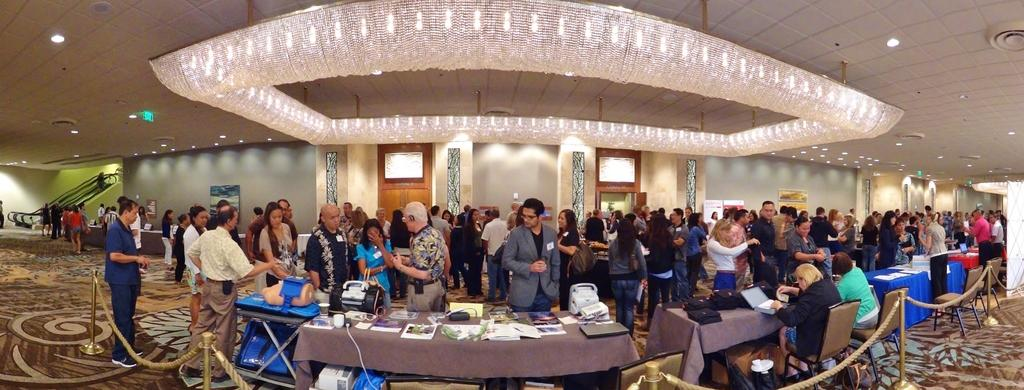What are the people in the image doing? There is a group of people standing on the floor, and there are people sitting on chairs. What is the arrangement of the chairs in the image? The chairs are in front of a table. What can be found on the table? There are objects on the table. What type of oranges can be seen on the island in the image? There is no island or oranges present in the image. What flavor of ice cream is being served at the event in the image? There is no mention of ice cream or any event in the image. 